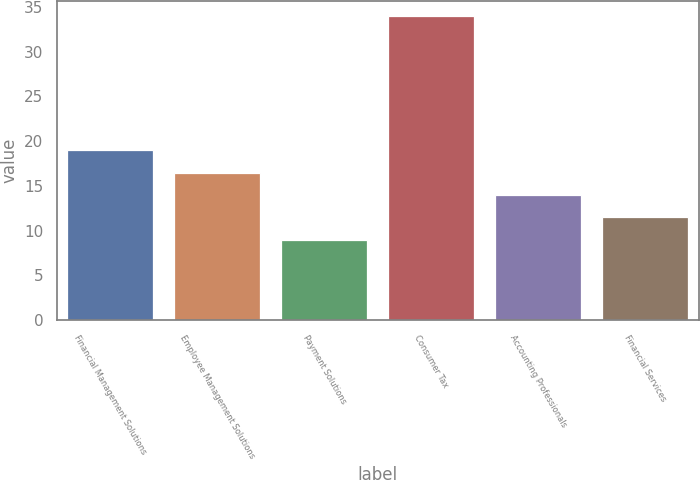Convert chart to OTSL. <chart><loc_0><loc_0><loc_500><loc_500><bar_chart><fcel>Financial Management Solutions<fcel>Employee Management Solutions<fcel>Payment Solutions<fcel>Consumer Tax<fcel>Accounting Professionals<fcel>Financial Services<nl><fcel>19<fcel>16.5<fcel>9<fcel>34<fcel>14<fcel>11.5<nl></chart> 